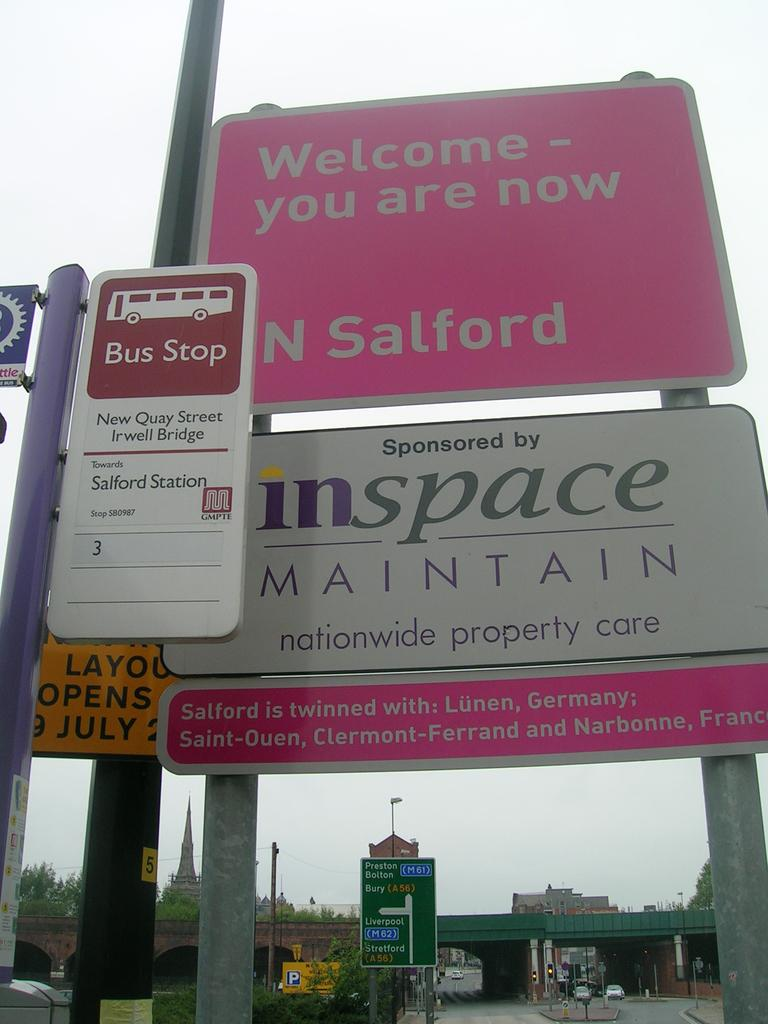<image>
Render a clear and concise summary of the photo. A street sign in pink with the location N Salford on it. 